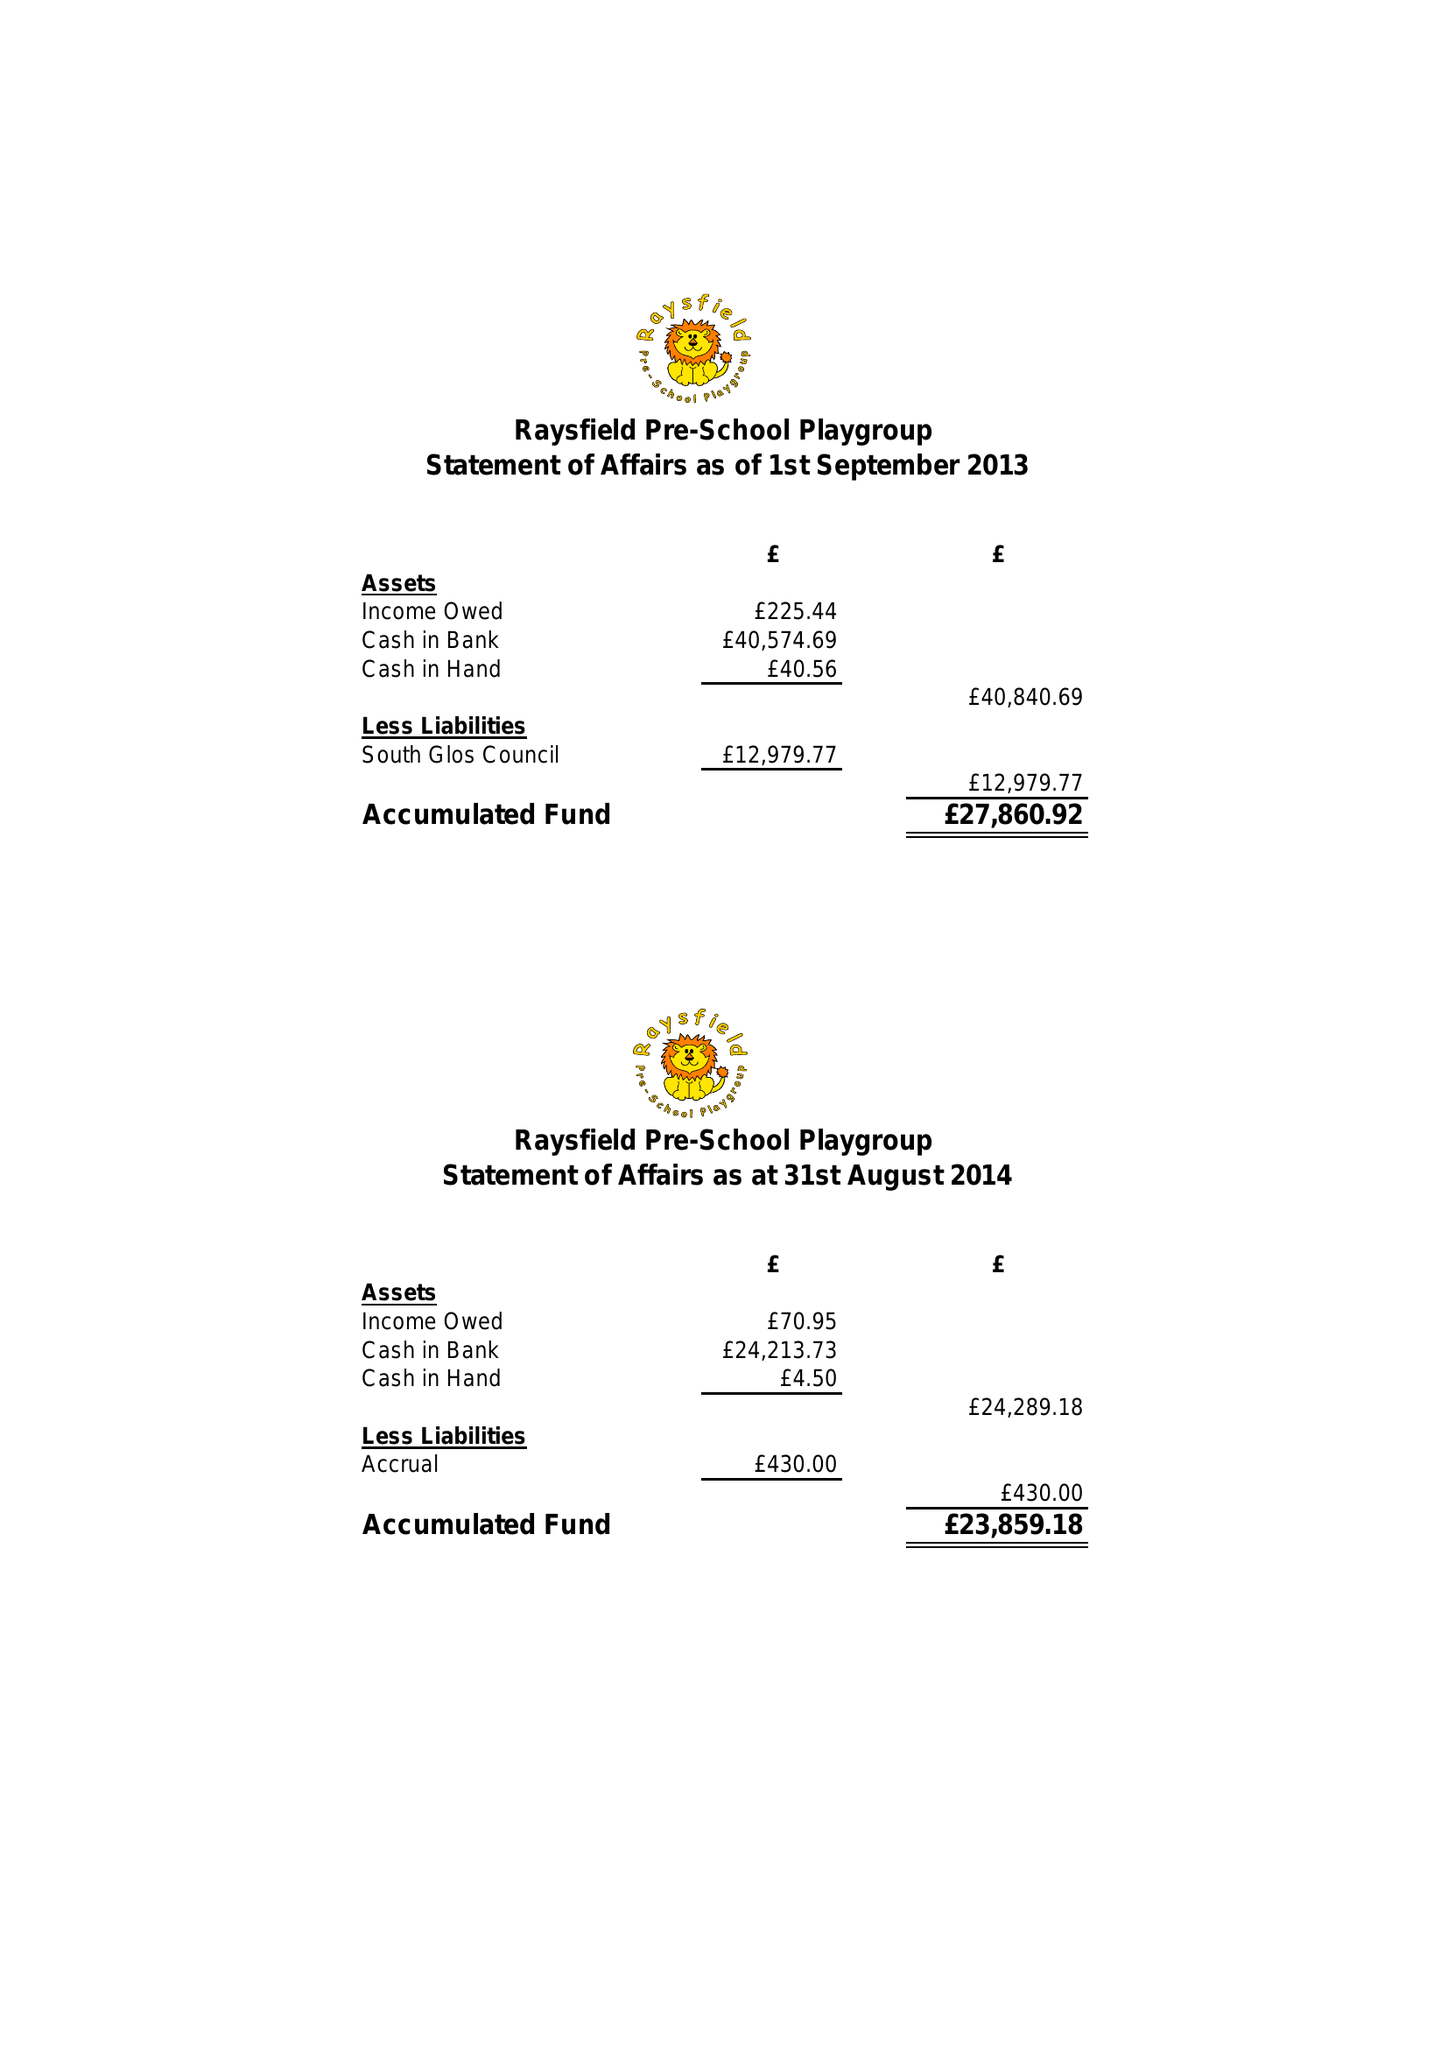What is the value for the charity_number?
Answer the question using a single word or phrase. 1027639 